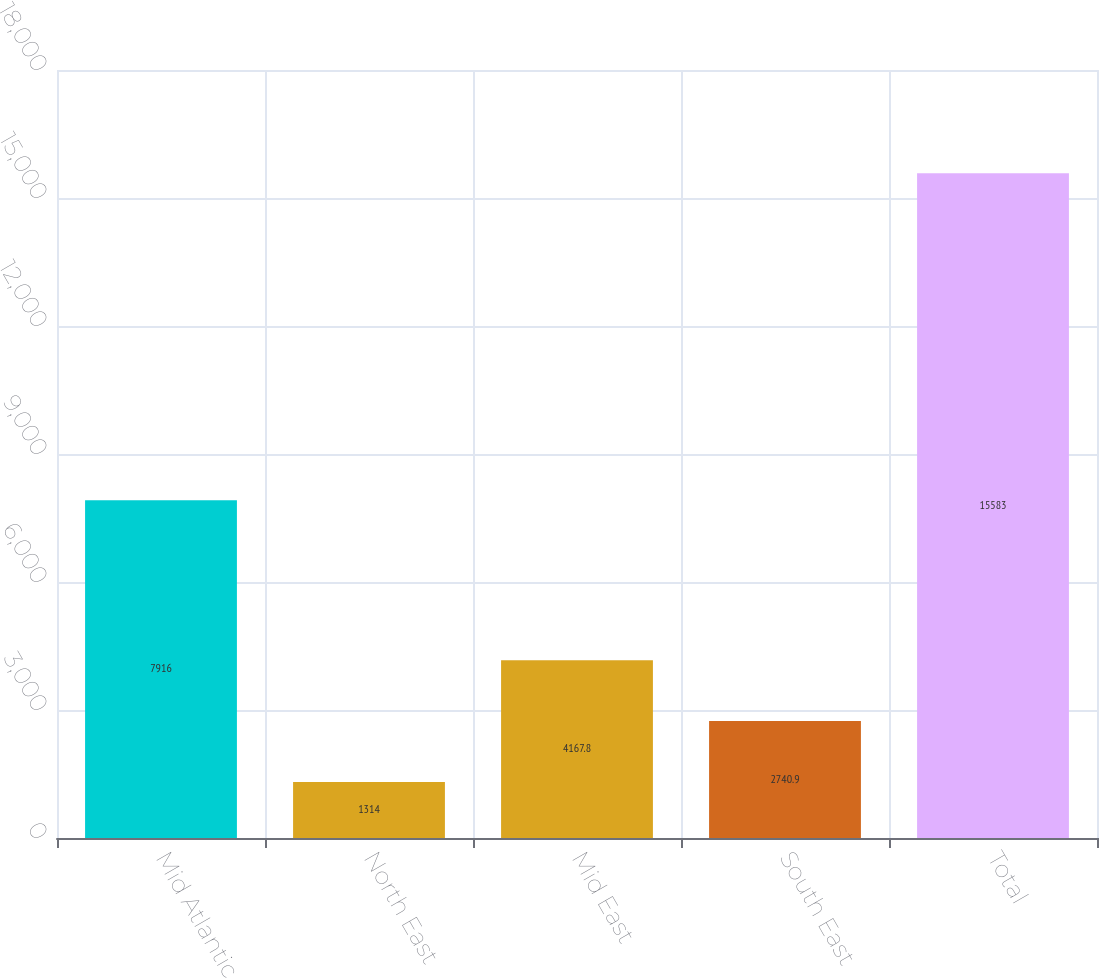<chart> <loc_0><loc_0><loc_500><loc_500><bar_chart><fcel>Mid Atlantic<fcel>North East<fcel>Mid East<fcel>South East<fcel>Total<nl><fcel>7916<fcel>1314<fcel>4167.8<fcel>2740.9<fcel>15583<nl></chart> 